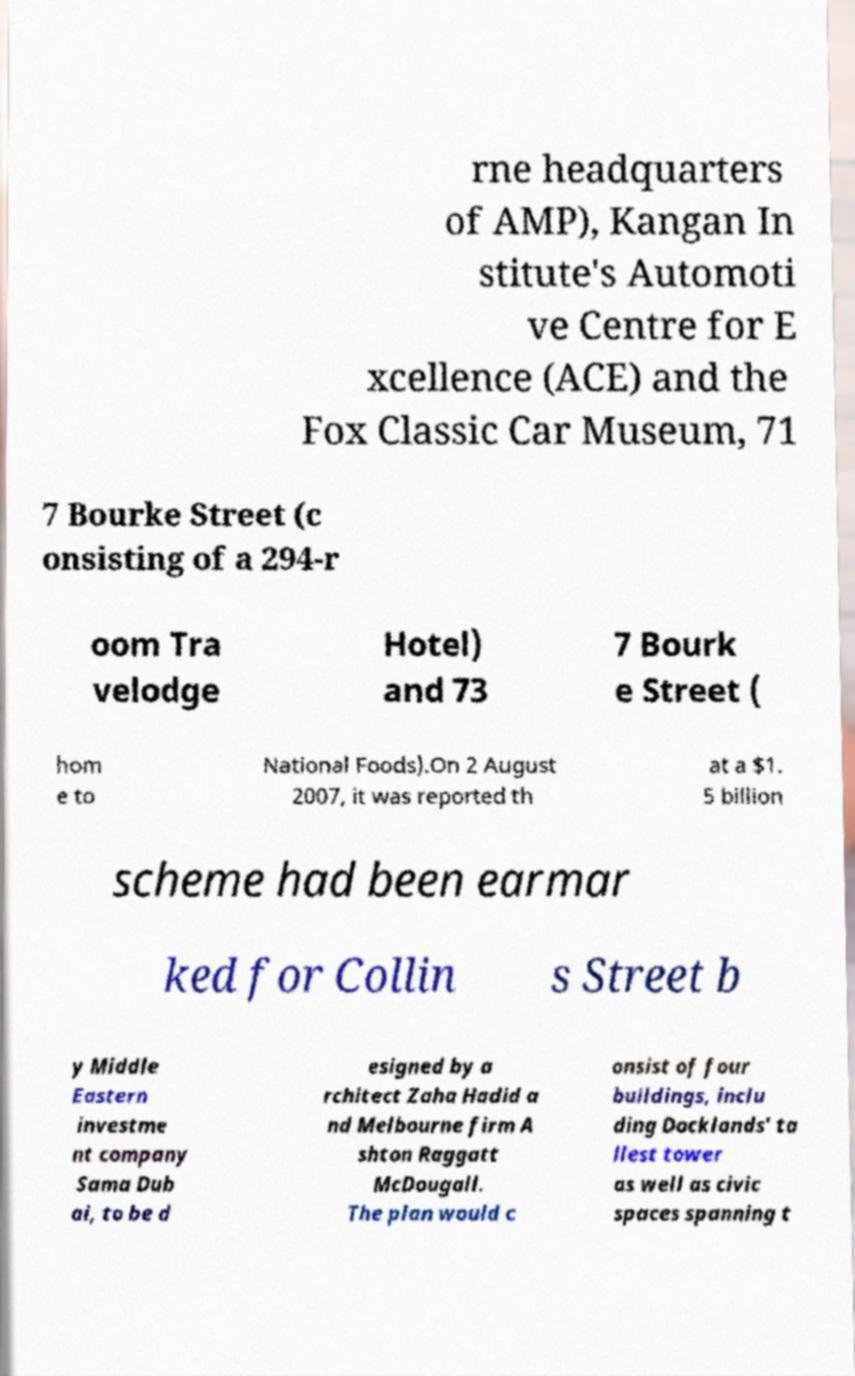What messages or text are displayed in this image? I need them in a readable, typed format. rne headquarters of AMP), Kangan In stitute's Automoti ve Centre for E xcellence (ACE) and the Fox Classic Car Museum, 71 7 Bourke Street (c onsisting of a 294-r oom Tra velodge Hotel) and 73 7 Bourk e Street ( hom e to National Foods).On 2 August 2007, it was reported th at a $1. 5 billion scheme had been earmar ked for Collin s Street b y Middle Eastern investme nt company Sama Dub ai, to be d esigned by a rchitect Zaha Hadid a nd Melbourne firm A shton Raggatt McDougall. The plan would c onsist of four buildings, inclu ding Docklands' ta llest tower as well as civic spaces spanning t 